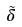<formula> <loc_0><loc_0><loc_500><loc_500>\tilde { \delta }</formula> 